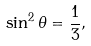<formula> <loc_0><loc_0><loc_500><loc_500>\sin ^ { 2 } \theta = \frac { 1 } { 3 } ,</formula> 